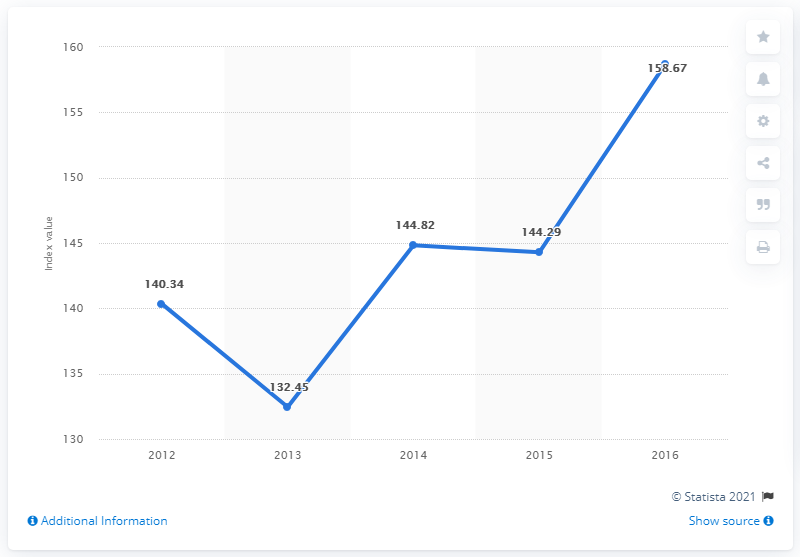Highlight a few significant elements in this photo. In 2016, the value of the Bloomberg USD Emerging Market Sovereign Bond Index was 158.67. 